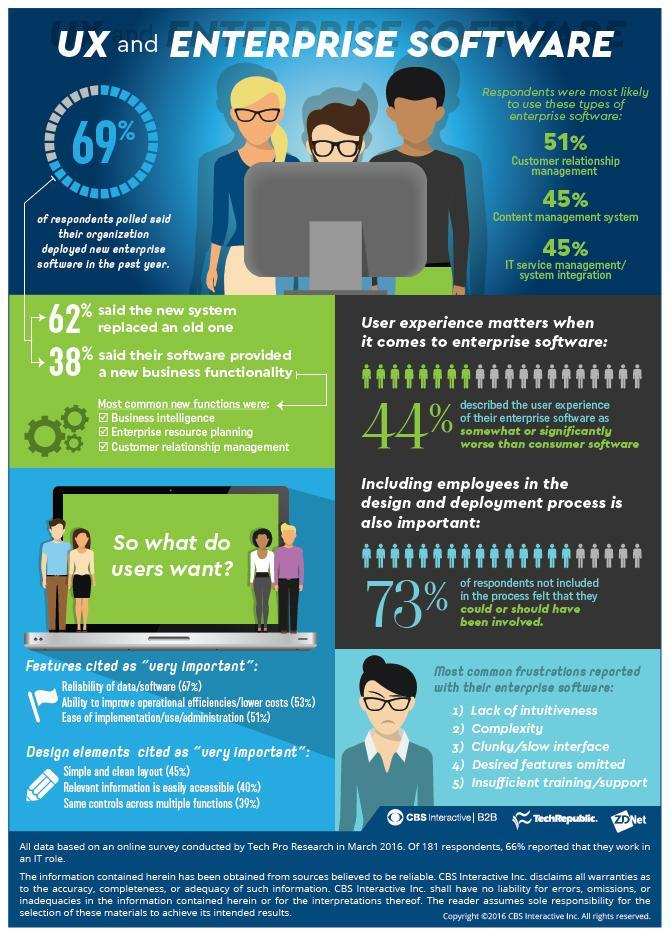What percentage of people did not said new system have replaced old one?
Answer the question with a short phrase. 38 What percentage of people did not said new software enabled new business functionality? 62 What percentage of employees believe new software is much better than their Company software? 44% What percentage of people are interested to deploy customer relationship management software? 51% 